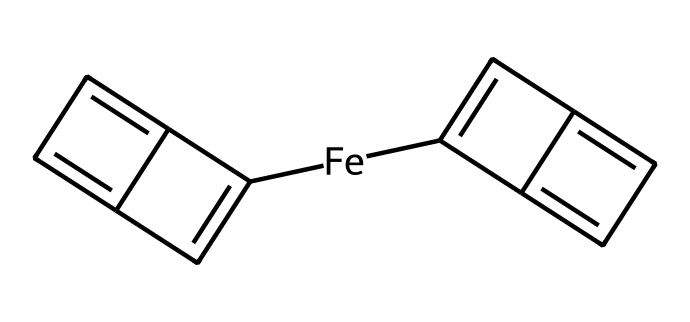What is the central metal atom in ferrocene? The chemical structure shows an iron atom (Fe) positioned in the center surrounded by two cyclopentadienyl anions.
Answer: iron How many carbon atoms are present in the structure of ferrocene? The structure includes two cyclopentadienyl rings, each containing five carbon atoms, totaling ten carbon atoms.
Answer: ten What type of bonding is primarily present in ferrocene? The bonding involves coordinate covalent bonds between the iron atom and the carbon atoms of the cyclopentadienyl rings.
Answer: coordinate covalent What is the overall molecular symmetry of ferrocene? The chemical structure depicts a symmetrical arrangement with two identical cyclopentadienyl rings around the iron atom, indicating D5h symmetry.
Answer: D5h How many pi electrons are involved in the bonding of ferrocene? Each cyclopentadienyl ring has six pi electrons (5 from the double bonds and 1 from the delocalization), leading to a total of ten pi electrons in the structure.
Answer: ten Why is ferrocene considered a stable organometallic compound? The stability arises from the strong bonding interactions between the central iron atom and the aromatic nature of the cyclopentadienyl rings, which allow for resonance.
Answer: strong bonding interactions What is the role of the cyclopentadienyl rings in ferrocene? The cyclopentadienyl rings act as ligands that stabilize the iron atom and contribute to its electronic properties, facilitating its use in electronic materials.
Answer: ligands 